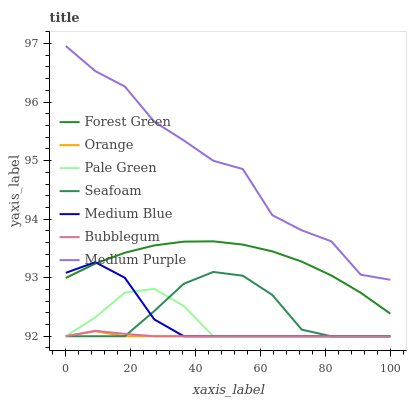Does Orange have the minimum area under the curve?
Answer yes or no. Yes. Does Medium Purple have the maximum area under the curve?
Answer yes or no. Yes. Does Seafoam have the minimum area under the curve?
Answer yes or no. No. Does Seafoam have the maximum area under the curve?
Answer yes or no. No. Is Bubblegum the smoothest?
Answer yes or no. Yes. Is Medium Purple the roughest?
Answer yes or no. Yes. Is Seafoam the smoothest?
Answer yes or no. No. Is Seafoam the roughest?
Answer yes or no. No. Does Medium Blue have the lowest value?
Answer yes or no. Yes. Does Medium Purple have the lowest value?
Answer yes or no. No. Does Medium Purple have the highest value?
Answer yes or no. Yes. Does Seafoam have the highest value?
Answer yes or no. No. Is Seafoam less than Forest Green?
Answer yes or no. Yes. Is Medium Purple greater than Bubblegum?
Answer yes or no. Yes. Does Orange intersect Bubblegum?
Answer yes or no. Yes. Is Orange less than Bubblegum?
Answer yes or no. No. Is Orange greater than Bubblegum?
Answer yes or no. No. Does Seafoam intersect Forest Green?
Answer yes or no. No. 